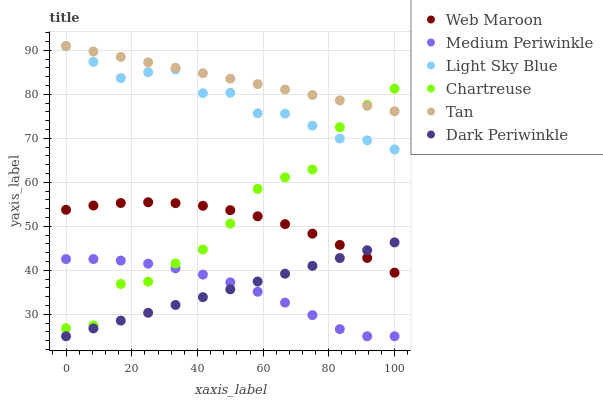Does Medium Periwinkle have the minimum area under the curve?
Answer yes or no. Yes. Does Tan have the maximum area under the curve?
Answer yes or no. Yes. Does Chartreuse have the minimum area under the curve?
Answer yes or no. No. Does Chartreuse have the maximum area under the curve?
Answer yes or no. No. Is Dark Periwinkle the smoothest?
Answer yes or no. Yes. Is Chartreuse the roughest?
Answer yes or no. Yes. Is Medium Periwinkle the smoothest?
Answer yes or no. No. Is Medium Periwinkle the roughest?
Answer yes or no. No. Does Medium Periwinkle have the lowest value?
Answer yes or no. Yes. Does Chartreuse have the lowest value?
Answer yes or no. No. Does Tan have the highest value?
Answer yes or no. Yes. Does Chartreuse have the highest value?
Answer yes or no. No. Is Web Maroon less than Light Sky Blue?
Answer yes or no. Yes. Is Light Sky Blue greater than Medium Periwinkle?
Answer yes or no. Yes. Does Tan intersect Chartreuse?
Answer yes or no. Yes. Is Tan less than Chartreuse?
Answer yes or no. No. Is Tan greater than Chartreuse?
Answer yes or no. No. Does Web Maroon intersect Light Sky Blue?
Answer yes or no. No. 